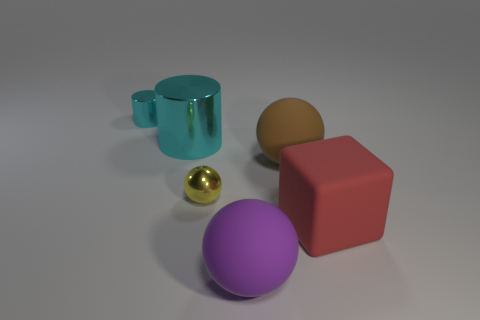Does the tiny cylinder have the same color as the large object on the left side of the yellow shiny sphere?
Offer a terse response. Yes. Are there any matte spheres of the same size as the brown thing?
Offer a very short reply. Yes. The other object that is the same color as the big shiny object is what size?
Your answer should be compact. Small. What is the material of the tiny object behind the tiny yellow shiny ball?
Provide a succinct answer. Metal. Is the number of tiny yellow shiny spheres on the right side of the tiny yellow shiny object the same as the number of cyan shiny cylinders that are on the right side of the small cyan cylinder?
Offer a terse response. No. There is a cyan metallic thing in front of the small cyan shiny cylinder; is its size the same as the shiny thing that is in front of the large brown sphere?
Give a very brief answer. No. What number of large metallic objects are the same color as the tiny cylinder?
Ensure brevity in your answer.  1. What material is the thing that is the same color as the tiny cylinder?
Your answer should be compact. Metal. Are there more small shiny things behind the tiny yellow ball than big cyan matte blocks?
Your response must be concise. Yes. Is the tiny cyan thing the same shape as the big cyan object?
Your answer should be very brief. Yes. 